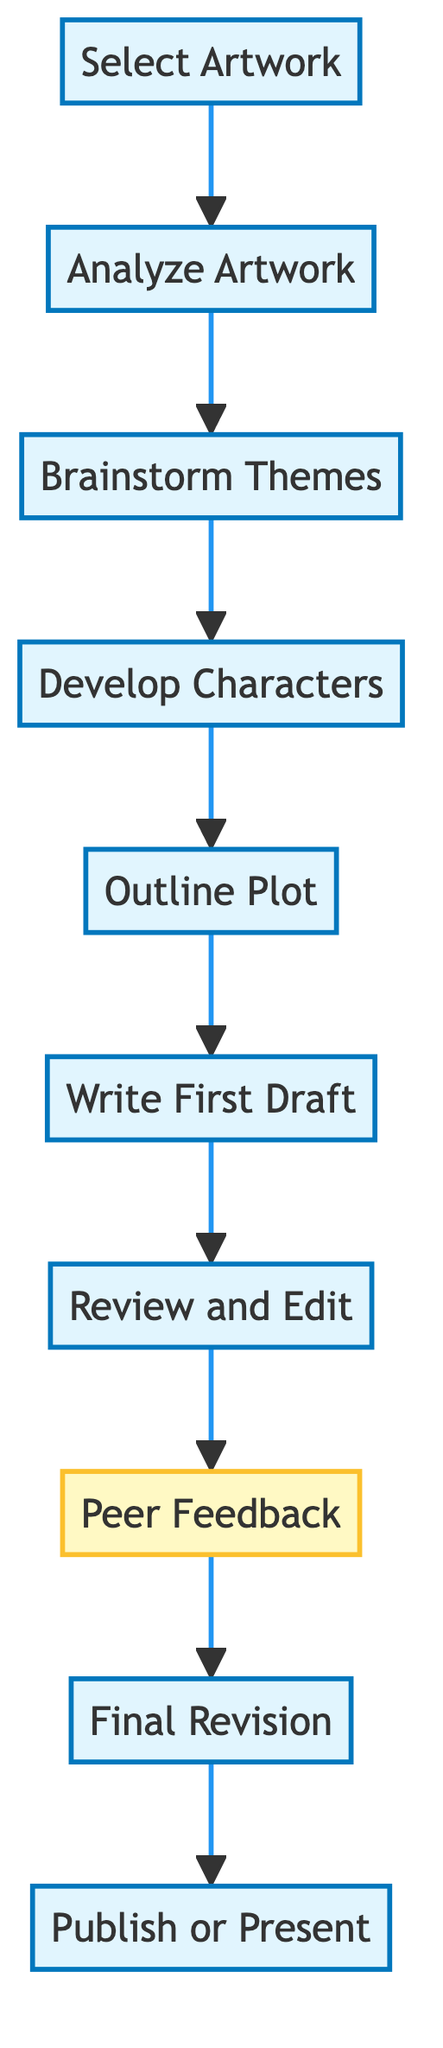What is the first step in the creative process? The diagram indicates that the first step is "Select Artwork," which is the initial action taken in the flow.
Answer: Select Artwork How many main steps are there in the diagram? By counting the number of individual steps listed in the diagram, there are a total of ten steps from "Select Artwork" to "Publish or Present."
Answer: 10 What step comes after "Brainstorm Themes"? The flowchart shows that "Develop Characters" follows "Brainstorm Themes," indicating the next action in the sequence.
Answer: Develop Characters Which step focuses on character creation? Analyzing the steps, "Develop Characters" specifically addresses the creation of characters based on the artwork.
Answer: Develop Characters What is the final step in the creative process? The last action in the diagram is labeled "Publish or Present," which completes the chain of events.
Answer: Publish or Present What happens after receiving peer feedback? According to the flowchart, the step that follows "Peer Feedback" is "Final Revision," indicating the next phase of development after feedback is received.
Answer: Final Revision Which steps involve writing? The steps that include writing are "Write First Draft" and "Review and Edit," indicating the iterative writing process in the flow.
Answer: Write First Draft, Review and Edit How many steps are there from analyzing the artwork to final revision? Counting the steps in the sequence from "Analyze Artwork" to "Final Revision," there are six steps in total.
Answer: 6 What is the main action during "Review and Edit"? The "Review and Edit" step focuses primarily on revising the draft, ensuring coherence and narrative flow.
Answer: Revise the draft Which specific step emphasizes collective input? The step labeled "Peer Feedback" directly emphasizes the gathering of constructive criticism from others.
Answer: Peer Feedback 